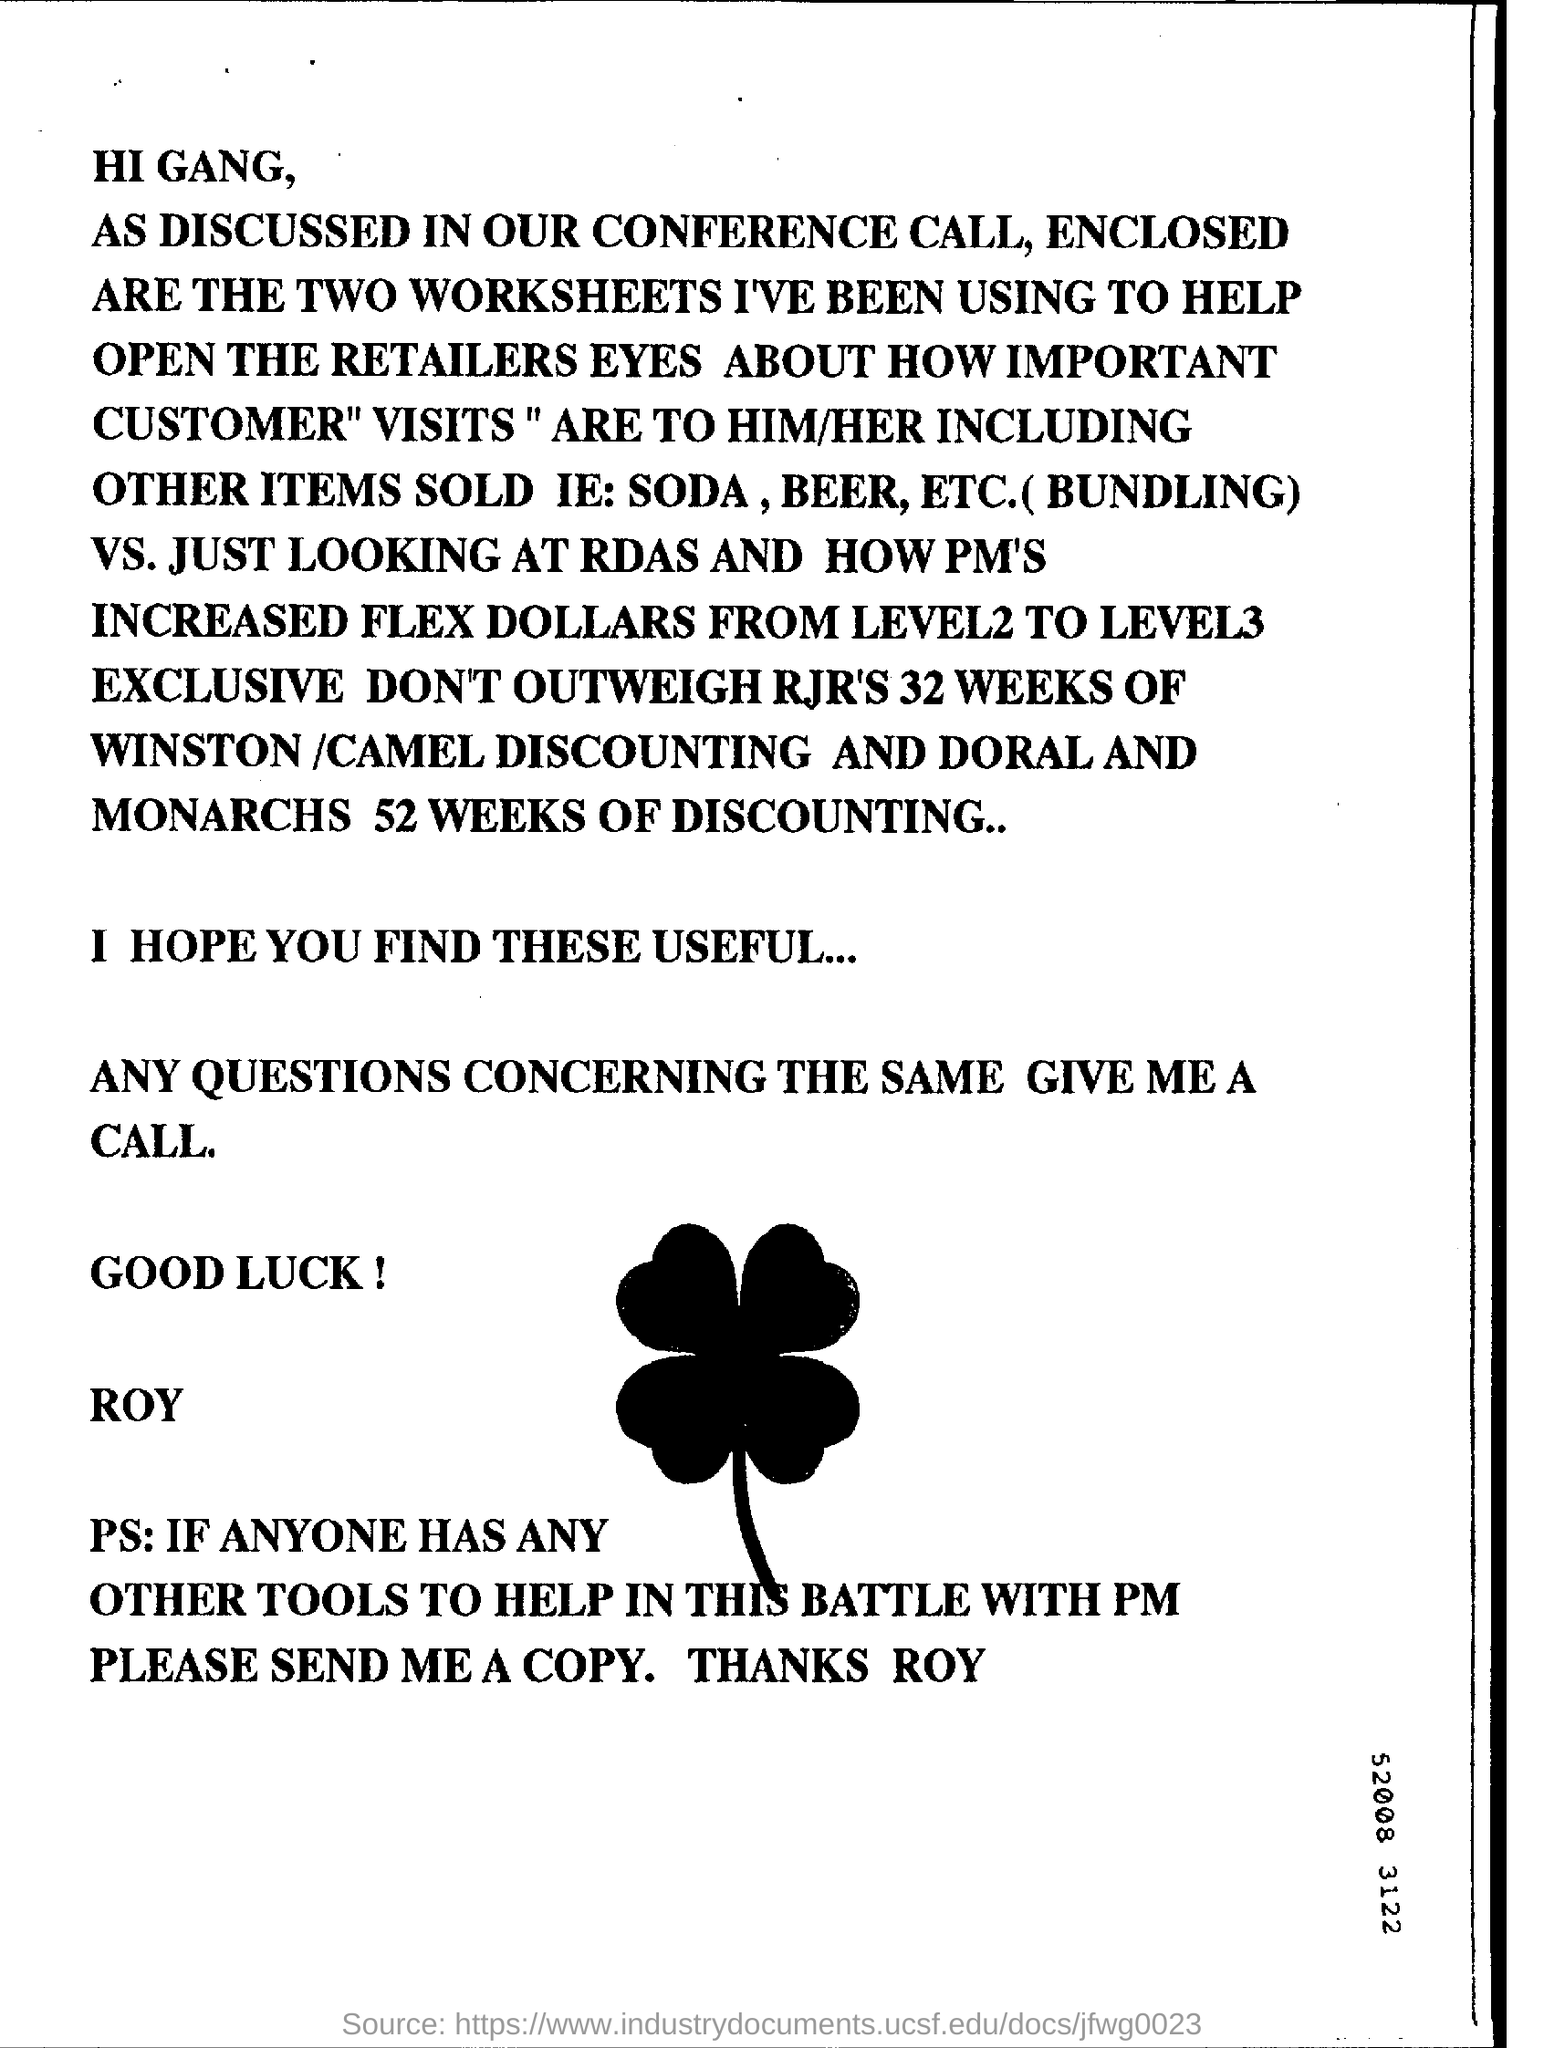Who has sent the letter ?
Your response must be concise. ROY. What is enclosed with the letter ?
Keep it short and to the point. TWO WORKSHEETS. How many weeks of discounting was given for doral and monarch brand of cigarettes?
Offer a terse response. 52 weeks. How many weeks of discounting was given for winston /camel brand of cigarettes?
Ensure brevity in your answer.  32 weeks. 